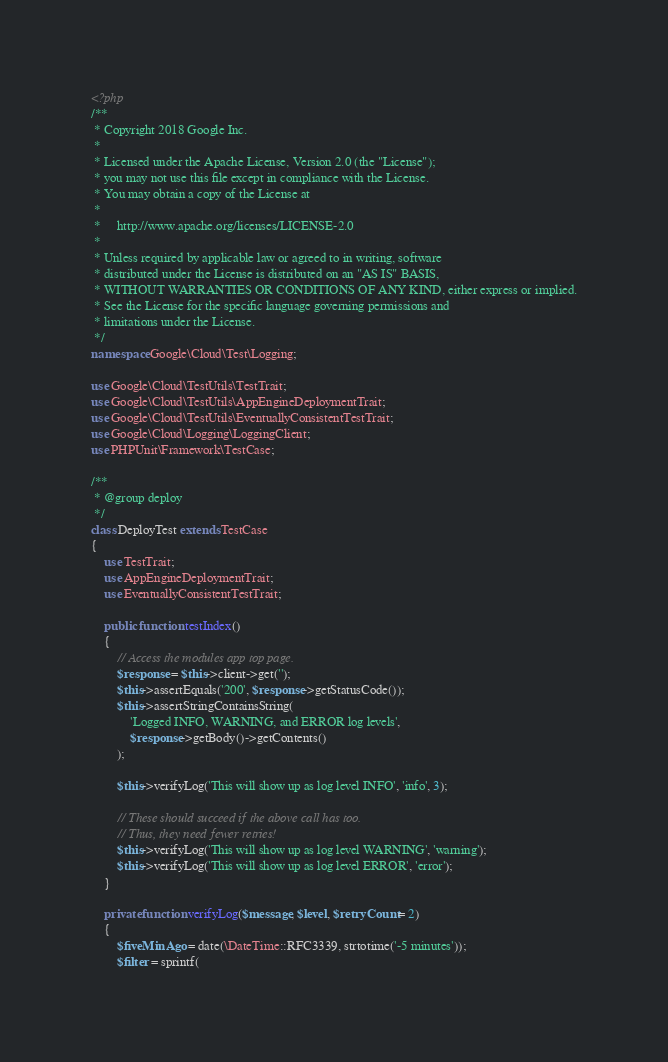<code> <loc_0><loc_0><loc_500><loc_500><_PHP_><?php
/**
 * Copyright 2018 Google Inc.
 *
 * Licensed under the Apache License, Version 2.0 (the "License");
 * you may not use this file except in compliance with the License.
 * You may obtain a copy of the License at
 *
 *     http://www.apache.org/licenses/LICENSE-2.0
 *
 * Unless required by applicable law or agreed to in writing, software
 * distributed under the License is distributed on an "AS IS" BASIS,
 * WITHOUT WARRANTIES OR CONDITIONS OF ANY KIND, either express or implied.
 * See the License for the specific language governing permissions and
 * limitations under the License.
 */
namespace Google\Cloud\Test\Logging;

use Google\Cloud\TestUtils\TestTrait;
use Google\Cloud\TestUtils\AppEngineDeploymentTrait;
use Google\Cloud\TestUtils\EventuallyConsistentTestTrait;
use Google\Cloud\Logging\LoggingClient;
use PHPUnit\Framework\TestCase;

/**
 * @group deploy
 */
class DeployTest extends TestCase
{
    use TestTrait;
    use AppEngineDeploymentTrait;
    use EventuallyConsistentTestTrait;

    public function testIndex()
    {
        // Access the modules app top page.
        $response = $this->client->get('');
        $this->assertEquals('200', $response->getStatusCode());
        $this->assertStringContainsString(
            'Logged INFO, WARNING, and ERROR log levels',
            $response->getBody()->getContents()
        );

        $this->verifyLog('This will show up as log level INFO', 'info', 3);

        // These should succeed if the above call has too.
        // Thus, they need fewer retries!
        $this->verifyLog('This will show up as log level WARNING', 'warning');
        $this->verifyLog('This will show up as log level ERROR', 'error');
    }

    private function verifyLog($message, $level, $retryCount = 2)
    {
        $fiveMinAgo = date(\DateTime::RFC3339, strtotime('-5 minutes'));
        $filter = sprintf(</code> 